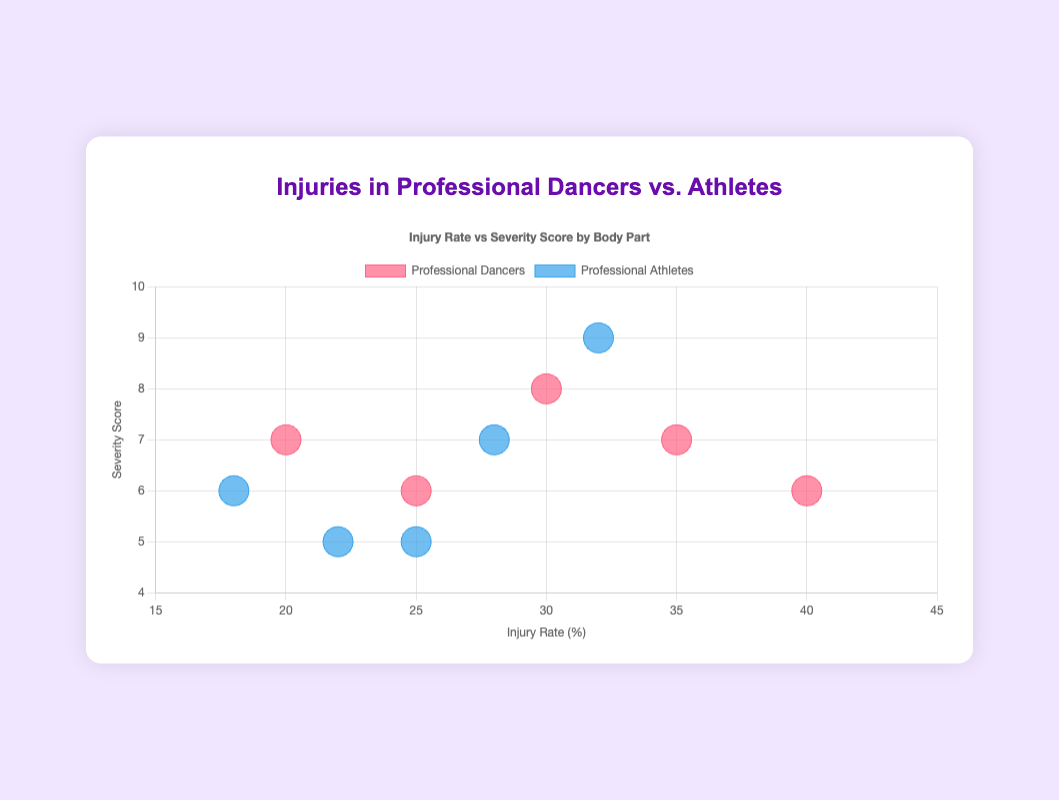What is the injury rate for the ankle in professional dancers? Refer to the dataset for professional dancers and find the injury rate for the ankle, which is 35.
Answer: 35% Which body part has the highest severity score among professional athletes? Look at the severity scores for professional athletes. The knee has the highest severity score of 9.
Answer: Knee How do the injury rates for the lower back compare between dancers and athletes? The injury rate for the lower back in professional dancers is 25, while it is 22 for professional athletes. This means the injury rate for dancers is higher by 3%.
Answer: Dancers have a higher rate What is the average severity score of injuries in professional dancers? Add the severity scores for professional dancers (7+8+6+7+6) and divide by the number of body parts (5). The calculation is (34/5) = 6.8.
Answer: 6.8 Which group has a larger bubble size for foot injuries, and what does that size represent? Compare the foot injury data for both groups, noting that the bubble sizes are equal, with an r value of 15, representing the injury rate. Both have the same bubble size.
Answer: Both groups are equal If you sum the injury rates for the knee, hip, and foot in professional athletes, what is the total? Add the injury rates for the knee (32), hip (18), and foot (25) in professional athletes. The total is (32+18+25) = 75.
Answer: 75% Which group has the lowest severity score for lower back injuries, and what is the score? For lower back injuries, compare the severity scores for dancers (6) and athletes (5). Athletes have the lower score.
Answer: Professional athletes, 5 How do the injury rates for the foot compare between professional dancers and athletes? The injury rate for the foot in professional dancers is 40, while for professional athletes, it is 25. Hence, dancers have a higher rate.
Answer: Dancers have a higher rate What can you infer about the relationship between injury rate and severity score in this chart? Observing the chart, one can infer that an increased injury rate does not necessarily correlate with a higher severity score, as seen in the foot injury with high rates but moderate severity in dancers.
Answer: No direct correlation In which group and body part do you see an equal severity score of 7, and how do their injury rates compare? Professional dancers have an equal severity score of 7 in ankle injuries (rate 35) and hip injuries (rate 20), while professional athletes have it only in ankle injuries (rate 28). Comparing these groups, the injury rate is higher in dancers’ ankles.
Answer: Professional dancers (ankle, hip), higher in ankle of dancers 